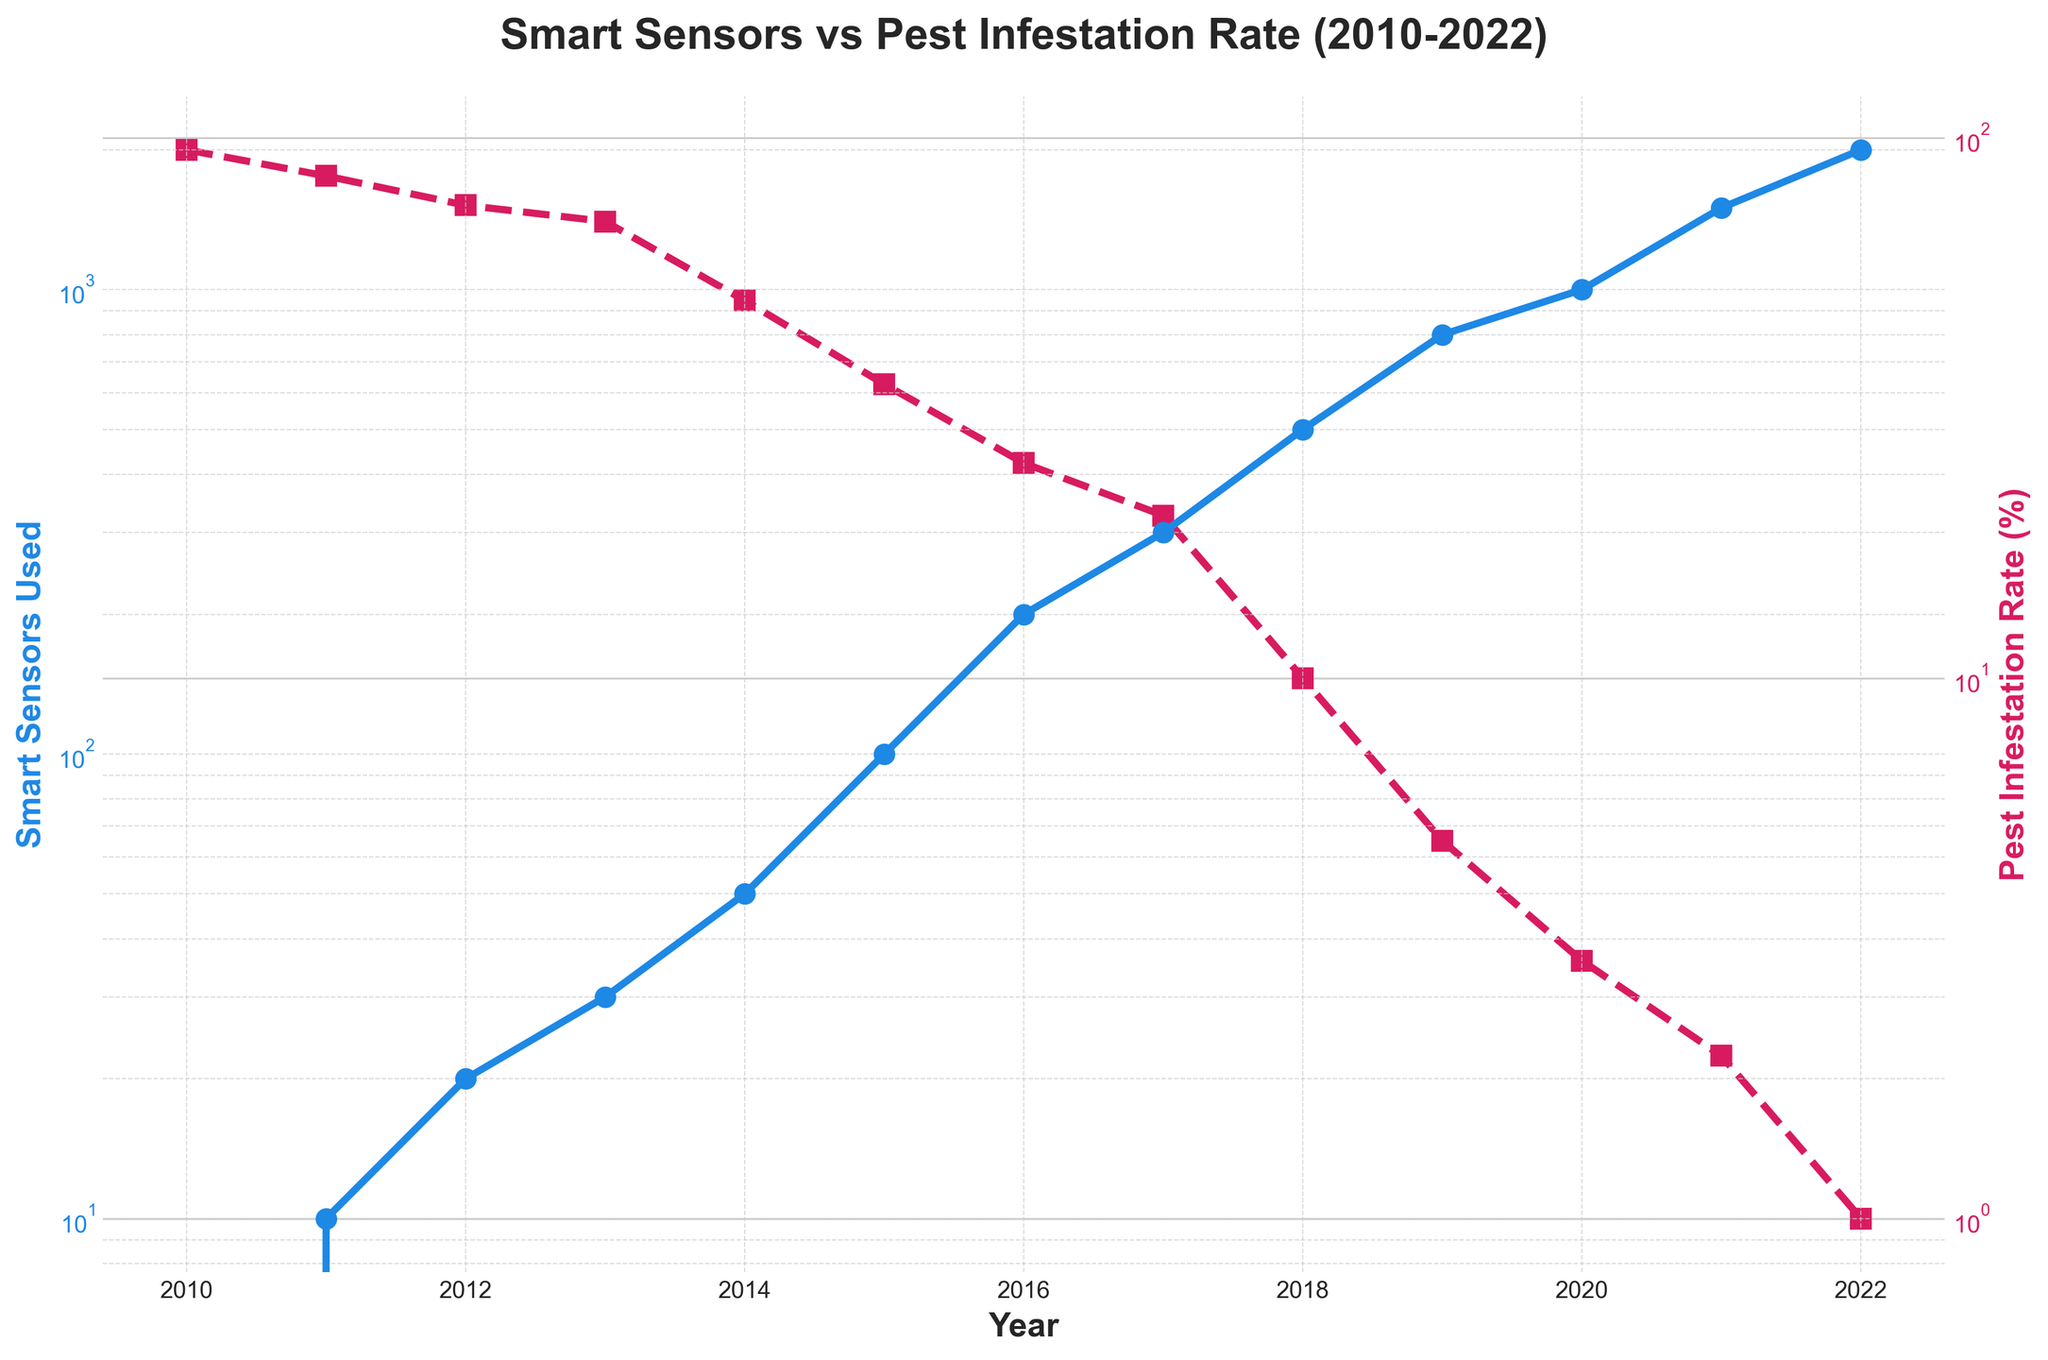What's the title of the figure? The title is located at the top of the figure and can be read directly.
Answer: Smart Sensors vs Pest Infestation Rate (2010-2022) How many data points are represented in the plot? By counting the years from 2010 to 2022, there are a total of 13 data points.
Answer: 13 In which year were approximately 1000 smart sensors used? Locate the year on the x-axis corresponding to the 1000 value on the left y-axis.
Answer: 2020 What was the pest infestation rate percentage in 2015? Find the year 2015 on the x-axis, then trace the pest infestation rate on the right y-axis.
Answer: 35% What is the general trend of smart sensors used from 2010 to 2022? From 2010 to 2022, there is a noticeable increase in the number of smart sensors used, shown by the upward curve.
Answer: Increasing Compare the pest infestation rate between 2012 and 2018. Which year had a lower pest infestation rate? Locate 2012 and 2018 on the x-axis and compare their pest infestation rates on the right y-axis.
Answer: 2018 What is the relationship between the number of smart sensors used and the pest infestation rate? As the number of smart sensors increases, the pest infestation rate generally decreases, indicating an inverse relationship.
Answer: Inverse relationship Identify the year with the highest pest infestation rate and the year with the lowest pest infestation rate. The highest rate is at the beginning in 2010, and the lowest rate is at the end in 2022, as indicated by the respective data points.
Answer: 2010 and 2022 Estimate the percentage drop in pest infestation rate from 2010 to 2022. The rate drops from 95% in 2010 to 1% in 2022, so the drop is (95 - 1)%.
Answer: 94% Is the y-axis of smart sensors and pest infestation rate linear or logarithmic? Both y-axes use a logarithmic scale, as indicated by the notation and scale marks.
Answer: Logarithmic 